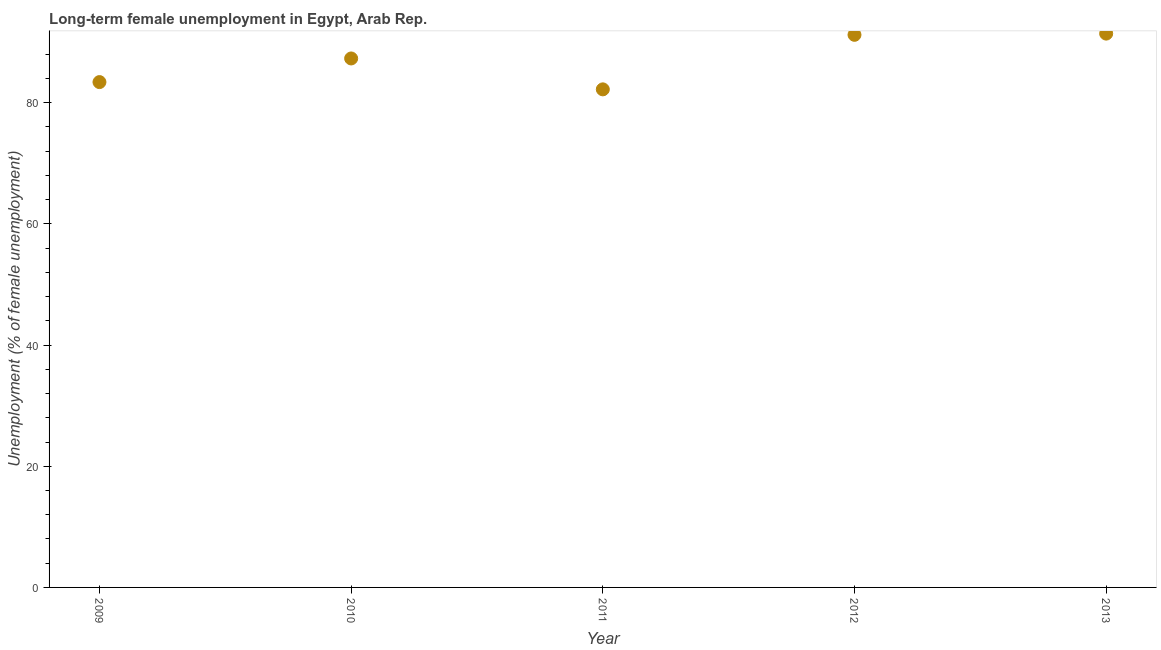What is the long-term female unemployment in 2012?
Your answer should be compact. 91.2. Across all years, what is the maximum long-term female unemployment?
Offer a very short reply. 91.4. Across all years, what is the minimum long-term female unemployment?
Offer a very short reply. 82.2. What is the sum of the long-term female unemployment?
Provide a succinct answer. 435.5. What is the difference between the long-term female unemployment in 2012 and 2013?
Your answer should be very brief. -0.2. What is the average long-term female unemployment per year?
Provide a short and direct response. 87.1. What is the median long-term female unemployment?
Your answer should be very brief. 87.3. What is the ratio of the long-term female unemployment in 2009 to that in 2010?
Offer a terse response. 0.96. Is the long-term female unemployment in 2010 less than that in 2012?
Provide a succinct answer. Yes. Is the difference between the long-term female unemployment in 2011 and 2013 greater than the difference between any two years?
Give a very brief answer. Yes. What is the difference between the highest and the second highest long-term female unemployment?
Ensure brevity in your answer.  0.2. What is the difference between the highest and the lowest long-term female unemployment?
Provide a short and direct response. 9.2. How many dotlines are there?
Your answer should be compact. 1. How many years are there in the graph?
Give a very brief answer. 5. What is the difference between two consecutive major ticks on the Y-axis?
Your response must be concise. 20. Does the graph contain any zero values?
Your answer should be compact. No. What is the title of the graph?
Give a very brief answer. Long-term female unemployment in Egypt, Arab Rep. What is the label or title of the X-axis?
Make the answer very short. Year. What is the label or title of the Y-axis?
Your response must be concise. Unemployment (% of female unemployment). What is the Unemployment (% of female unemployment) in 2009?
Make the answer very short. 83.4. What is the Unemployment (% of female unemployment) in 2010?
Your response must be concise. 87.3. What is the Unemployment (% of female unemployment) in 2011?
Your answer should be very brief. 82.2. What is the Unemployment (% of female unemployment) in 2012?
Give a very brief answer. 91.2. What is the Unemployment (% of female unemployment) in 2013?
Provide a short and direct response. 91.4. What is the difference between the Unemployment (% of female unemployment) in 2009 and 2011?
Give a very brief answer. 1.2. What is the difference between the Unemployment (% of female unemployment) in 2009 and 2013?
Offer a terse response. -8. What is the difference between the Unemployment (% of female unemployment) in 2010 and 2011?
Your answer should be compact. 5.1. What is the difference between the Unemployment (% of female unemployment) in 2010 and 2012?
Offer a terse response. -3.9. What is the difference between the Unemployment (% of female unemployment) in 2010 and 2013?
Provide a short and direct response. -4.1. What is the difference between the Unemployment (% of female unemployment) in 2011 and 2012?
Offer a terse response. -9. What is the difference between the Unemployment (% of female unemployment) in 2012 and 2013?
Provide a short and direct response. -0.2. What is the ratio of the Unemployment (% of female unemployment) in 2009 to that in 2010?
Keep it short and to the point. 0.95. What is the ratio of the Unemployment (% of female unemployment) in 2009 to that in 2011?
Give a very brief answer. 1.01. What is the ratio of the Unemployment (% of female unemployment) in 2009 to that in 2012?
Offer a very short reply. 0.91. What is the ratio of the Unemployment (% of female unemployment) in 2009 to that in 2013?
Provide a short and direct response. 0.91. What is the ratio of the Unemployment (% of female unemployment) in 2010 to that in 2011?
Your answer should be very brief. 1.06. What is the ratio of the Unemployment (% of female unemployment) in 2010 to that in 2012?
Keep it short and to the point. 0.96. What is the ratio of the Unemployment (% of female unemployment) in 2010 to that in 2013?
Your answer should be compact. 0.95. What is the ratio of the Unemployment (% of female unemployment) in 2011 to that in 2012?
Provide a succinct answer. 0.9. What is the ratio of the Unemployment (% of female unemployment) in 2011 to that in 2013?
Your answer should be very brief. 0.9. What is the ratio of the Unemployment (% of female unemployment) in 2012 to that in 2013?
Give a very brief answer. 1. 